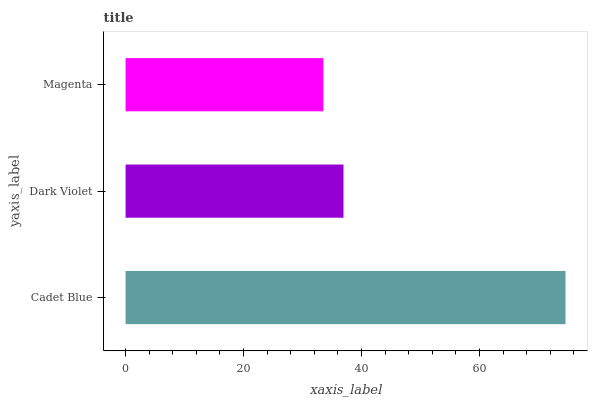Is Magenta the minimum?
Answer yes or no. Yes. Is Cadet Blue the maximum?
Answer yes or no. Yes. Is Dark Violet the minimum?
Answer yes or no. No. Is Dark Violet the maximum?
Answer yes or no. No. Is Cadet Blue greater than Dark Violet?
Answer yes or no. Yes. Is Dark Violet less than Cadet Blue?
Answer yes or no. Yes. Is Dark Violet greater than Cadet Blue?
Answer yes or no. No. Is Cadet Blue less than Dark Violet?
Answer yes or no. No. Is Dark Violet the high median?
Answer yes or no. Yes. Is Dark Violet the low median?
Answer yes or no. Yes. Is Magenta the high median?
Answer yes or no. No. Is Cadet Blue the low median?
Answer yes or no. No. 